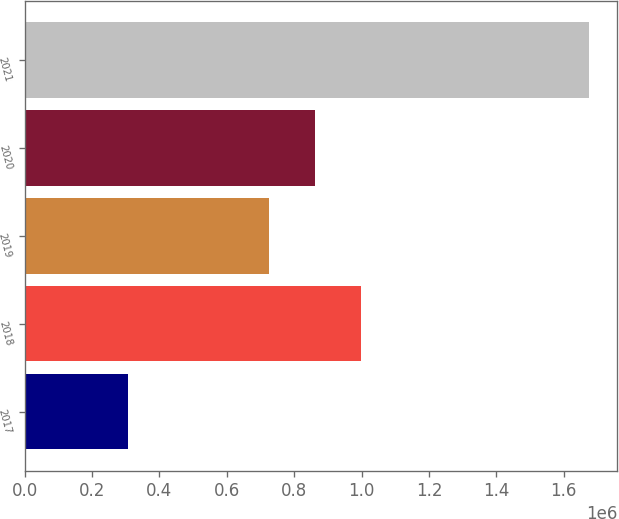<chart> <loc_0><loc_0><loc_500><loc_500><bar_chart><fcel>2017<fcel>2018<fcel>2019<fcel>2020<fcel>2021<nl><fcel>307403<fcel>998328<fcel>724899<fcel>861614<fcel>1.67455e+06<nl></chart> 